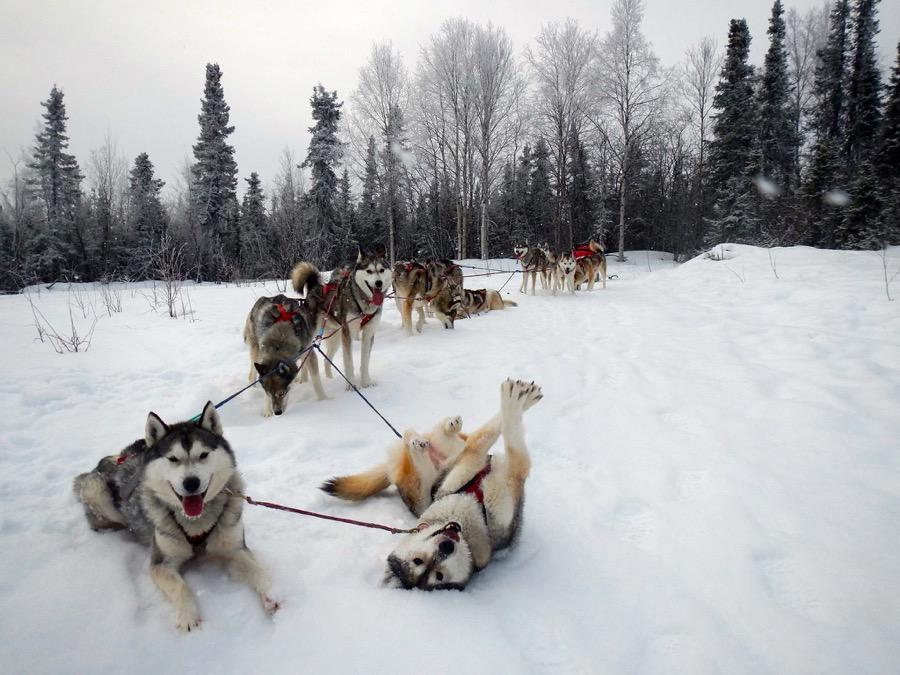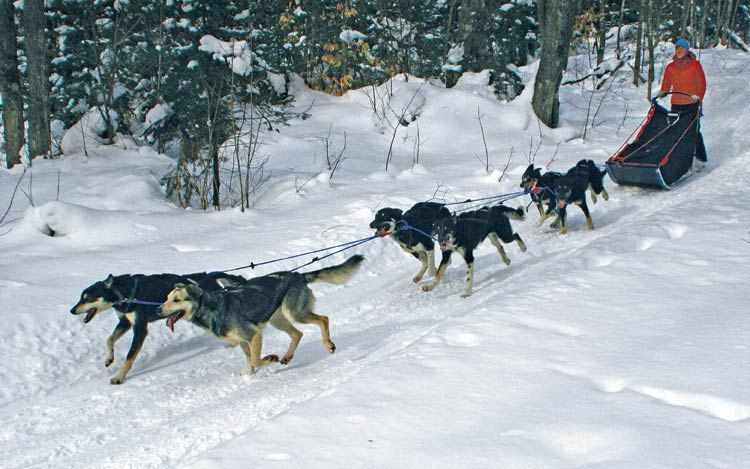The first image is the image on the left, the second image is the image on the right. Analyze the images presented: Is the assertion "Each image includes a sled dog team facing away from the camera toward a trail lined with trees." valid? Answer yes or no. No. The first image is the image on the left, the second image is the image on the right. Given the left and right images, does the statement "In one of the images, at least eight sled dogs are resting in the snow." hold true? Answer yes or no. Yes. 